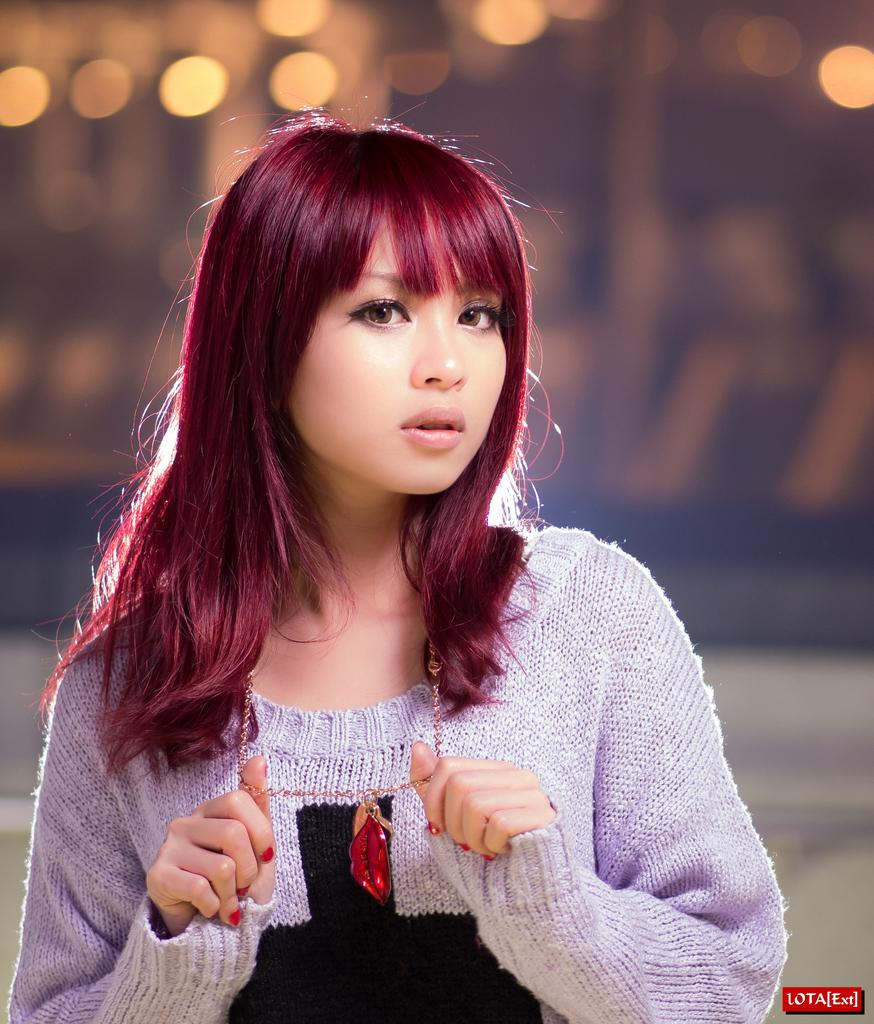Who is the main subject in the image? There is a lady in the center of the image. What can be seen in the background of the image? There are lights in the background of the image. Is there any text present in the image? Yes, there is some text at the bottom of the image. How does the beggar interact with the canvas in the image? There is no beggar or canvas present in the image. What type of business is being conducted in the image? The image does not depict any business activity. 